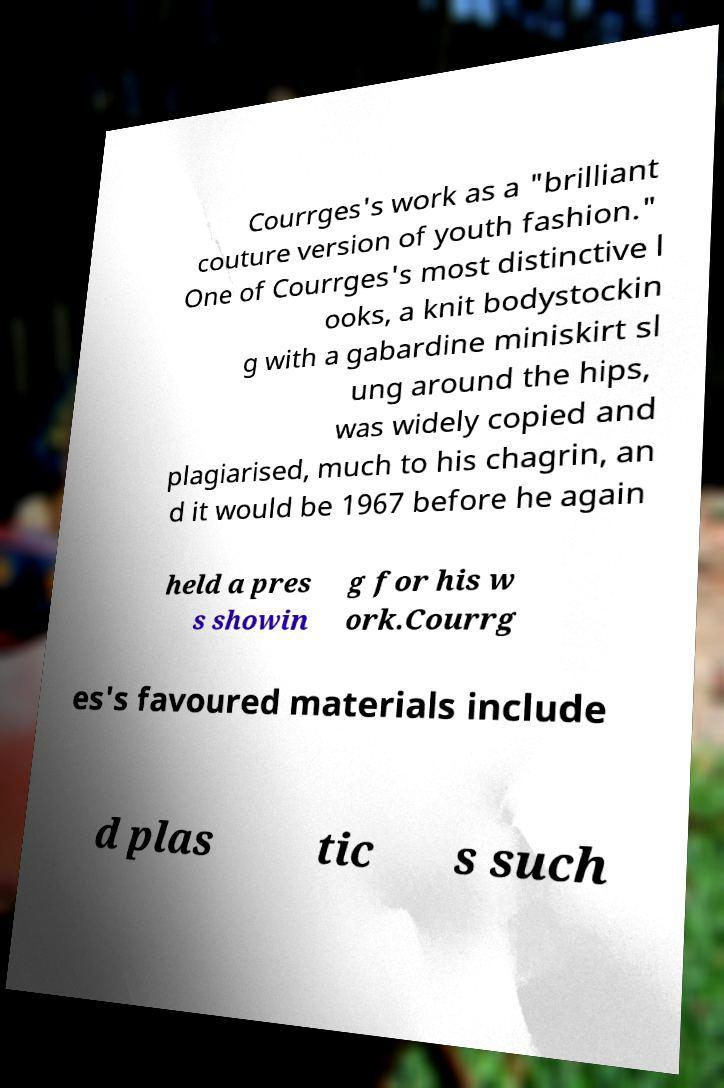Could you assist in decoding the text presented in this image and type it out clearly? Courrges's work as a "brilliant couture version of youth fashion." One of Courrges's most distinctive l ooks, a knit bodystockin g with a gabardine miniskirt sl ung around the hips, was widely copied and plagiarised, much to his chagrin, an d it would be 1967 before he again held a pres s showin g for his w ork.Courrg es's favoured materials include d plas tic s such 